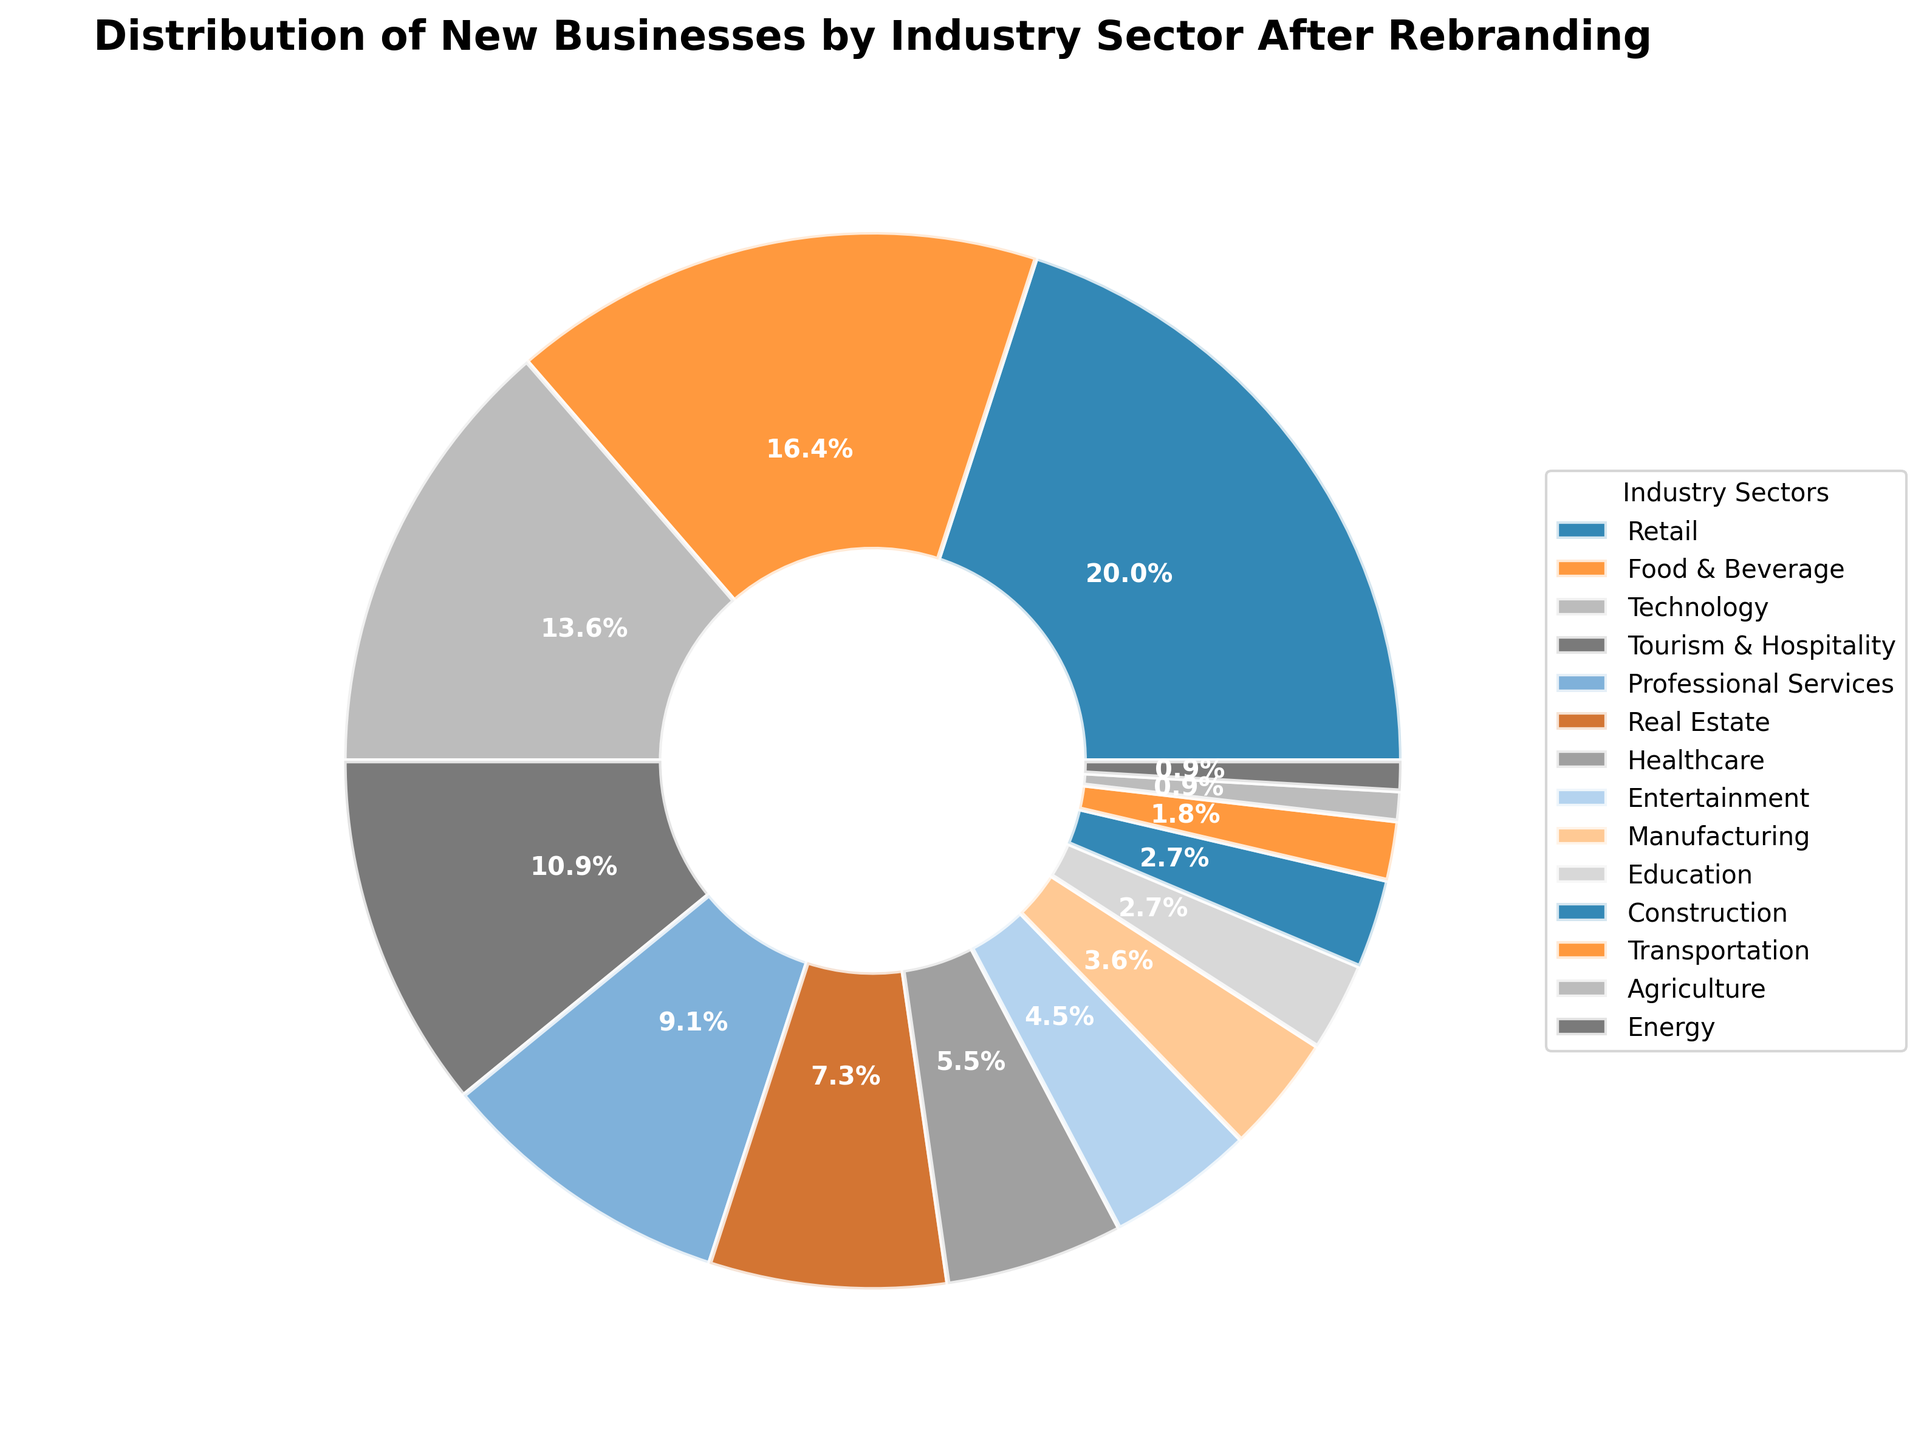What industry sector has the highest percentage of new businesses? The Retail sector has the highest percentage share, indicated by the largest segment in the pie chart and the label showing 22%.
Answer: Retail Which two sectors together constitute 30% of the new businesses? Adding the percentages of Agriculture (1%), Education (3%), Construction (3%), and Energy (1%), the sum is 8%. Therefore, adding other sectors until the sum reaches around 30%, we find that Professional Services (10%) and Tourism & Hospitality (12%) together make 30% along with Healthcare (6%) and Entertainment (5%).
Answer: Professional Services and Tourism & Hospitality How many industry sectors have a percentage share less than 5%? The sectors with less than 5% share are Manufacturing, Education, Construction, Transportation, Agriculture, and Energy, making a total of 6 sectors.
Answer: 6 Which sector has a slightly higher percentage of new businesses, Healthcare or Entertainment? Comparing Healthcare (6%) and Entertainment (5%), Healthcare has a slightly higher percentage.
Answer: Healthcare What is the combined percentage of Technology and Real Estate? By adding the percentages of Technology (15%) and Real Estate (8%), we get 23%.
Answer: 23% If you add the percentages of Food & Beverage and Technology, does it exceed Retail? Adding Food & Beverage (18%) and Technology (15%) gives us 33%, which is greater than Retail's 22%.
Answer: Yes What percentage of new businesses is constituted by sectors other than the top three (Retail, Food & Beverage, Technology)? Subtracting the sum of the top three sectors (22% + 18% + 15% = 55%) from 100%, we get 45%.
Answer: 45% How much larger is the percentage share of Food & Beverage compared to Construction? The percentage share of Food & Beverage (18%) minus Construction (3%) equals 15%.
Answer: 15% Arrange the following sectors in ascending order of their percentage shares: Tourism & Hospitality, Professional Services, and Real Estate. Tourism & Hospitality (12%), Professional Services (10%), and Real Estate (8%) in ascending order are Real Estate, Professional Services, Tourism & Hospitality.
Answer: Real Estate, Professional Services, Tourism & Hospitality Do any two sectors have an equal percentage share of new businesses? Yes, both Education and Construction have a percentage share of 3%.
Answer: Yes 